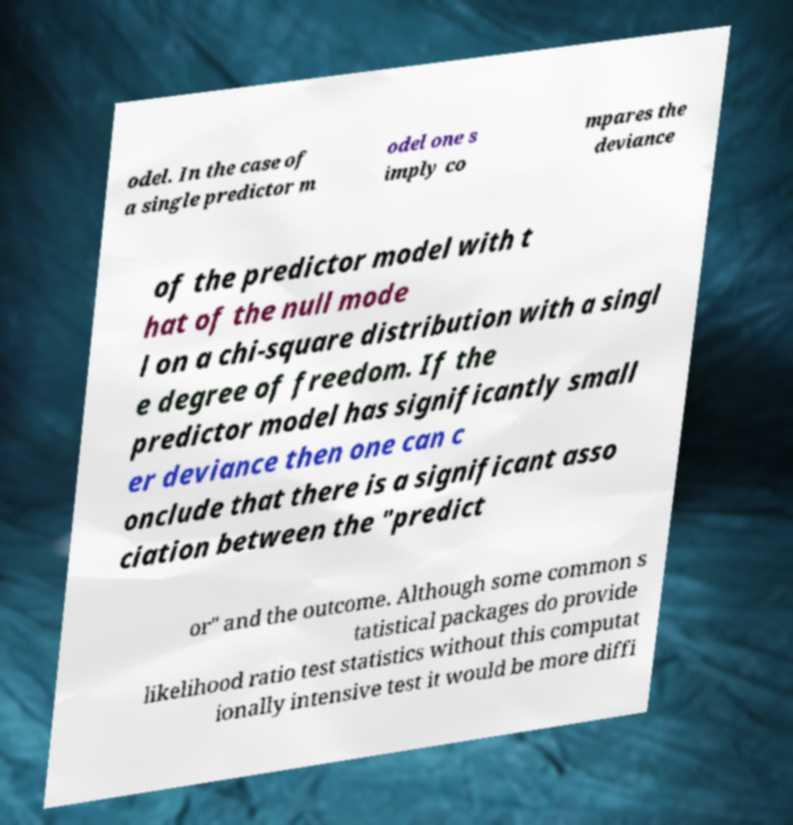Could you assist in decoding the text presented in this image and type it out clearly? odel. In the case of a single predictor m odel one s imply co mpares the deviance of the predictor model with t hat of the null mode l on a chi-square distribution with a singl e degree of freedom. If the predictor model has significantly small er deviance then one can c onclude that there is a significant asso ciation between the "predict or" and the outcome. Although some common s tatistical packages do provide likelihood ratio test statistics without this computat ionally intensive test it would be more diffi 